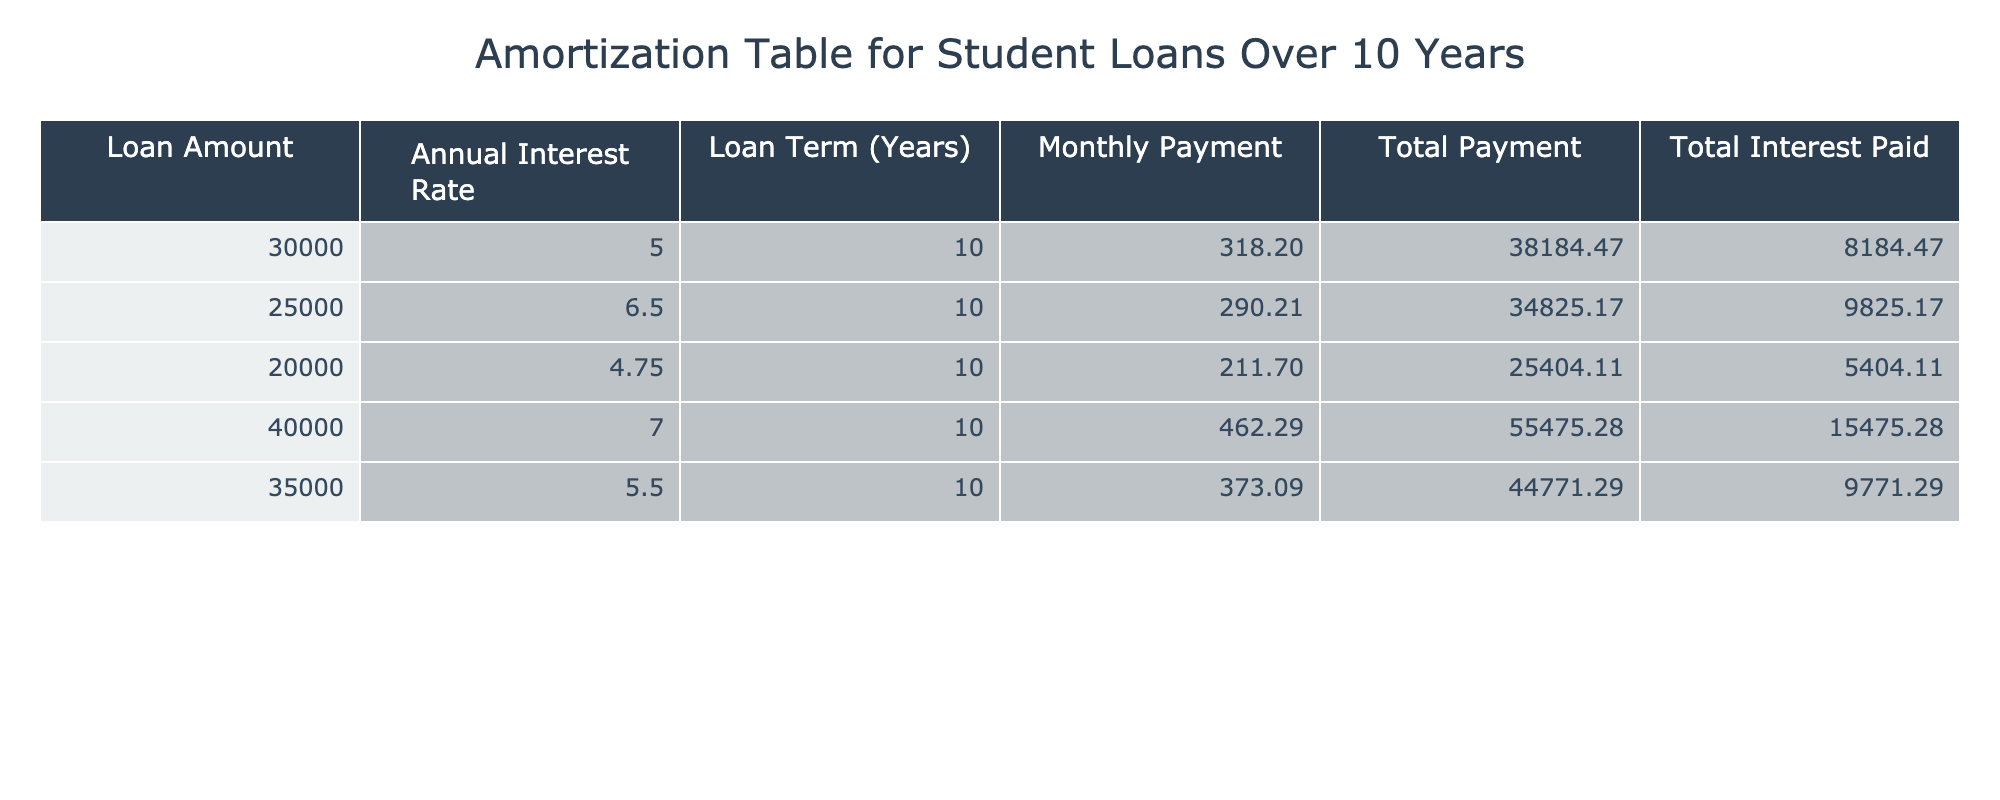What is the monthly payment for a loan amount of 30000? The table lists the monthly payment for each loan amount under the "Monthly Payment" column. For a loan amount of 30000, the corresponding monthly payment is 318.20.
Answer: 318.20 Which loan has the highest total interest paid? By reviewing the "Total Interest Paid" column, the loan with the highest value is 15475.28, which corresponds to the loan amount of 40000, indicating it has the highest total interest.
Answer: 40000 What is the difference in total payments between the loans of 25000 and 20000? The total payments for the loans of 25000 and 20000 are 34825.17 and 25404.11, respectively. The difference can be calculated as 34825.17 - 25404.11 = 9411.06.
Answer: 9411.06 Is the total interest paid for a loan amount of 35000 greater than that for a loan amount of 30000? Checking the "Total Interest Paid" column, for 35000 the total interest is 9771.29, while for 30000, it is 8184.47. Since 9771.29 is greater than 8184.47, the statement is true.
Answer: Yes What is the average monthly payment for all the loans listed? To find the average monthly payment, sum the monthly payments: (318.20 + 290.21 + 211.70 + 462.29 + 373.09) = 1655.49. Then divide by the number of loans (5): 1655.49 / 5 = 331.098.
Answer: 331.10 